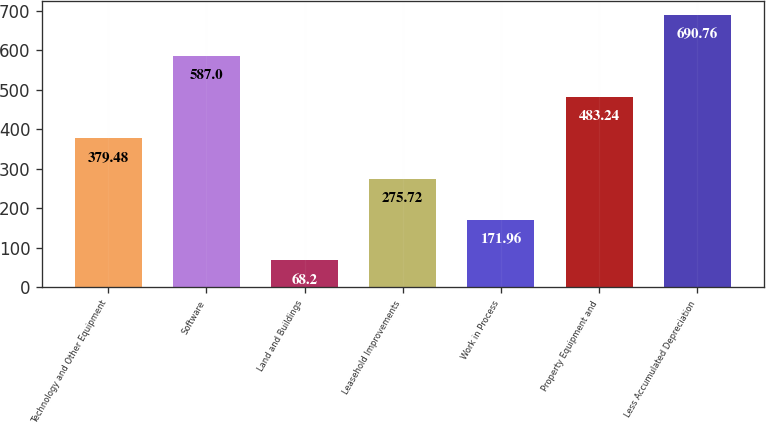<chart> <loc_0><loc_0><loc_500><loc_500><bar_chart><fcel>Technology and Other Equipment<fcel>Software<fcel>Land and Buildings<fcel>Leasehold Improvements<fcel>Work in Process<fcel>Property Equipment and<fcel>Less Accumulated Depreciation<nl><fcel>379.48<fcel>587<fcel>68.2<fcel>275.72<fcel>171.96<fcel>483.24<fcel>690.76<nl></chart> 